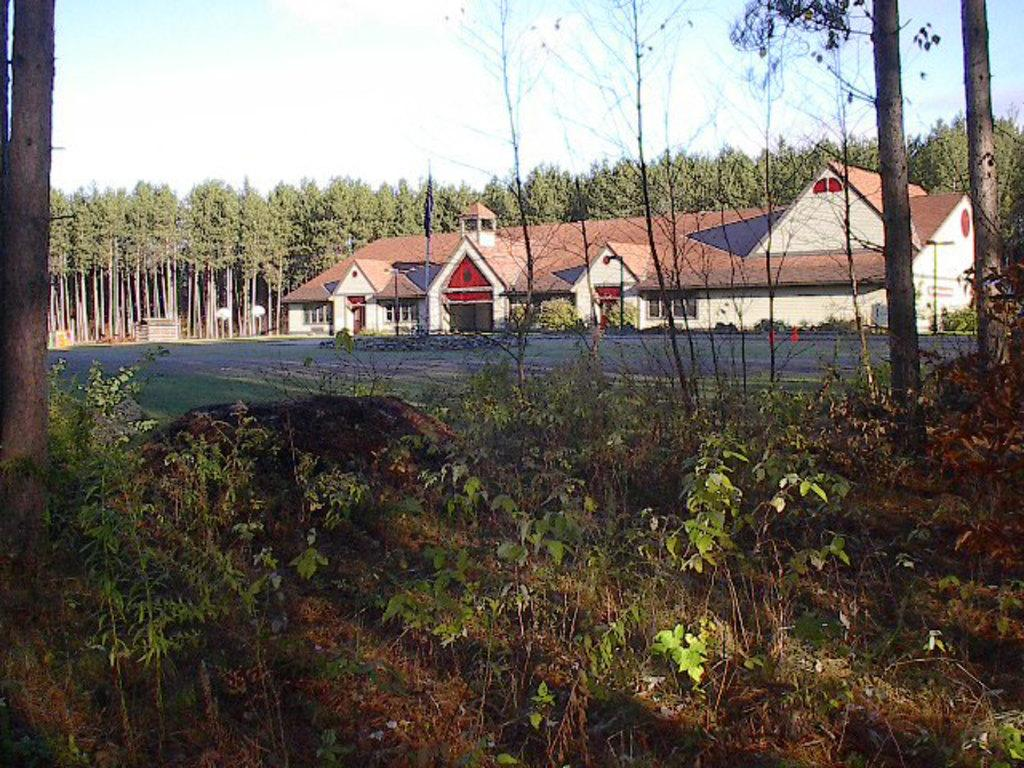What type of vegetation is at the bottom of the image? There are plants at the bottom of the image. What structures are located in the middle of the image? There are houses in the middle of the image. What type of vegetation is at the back side of the image? There are trees at the back side of the image. What is visible at the top of the image? The sky is visible at the top of the image. What type of shame can be seen in the image? There is no shame present in the image; it features plants, houses, trees, and the sky. What act is being performed by the trees in the image? The trees are not performing any act in the image; they are stationary and provide a natural backdrop. 